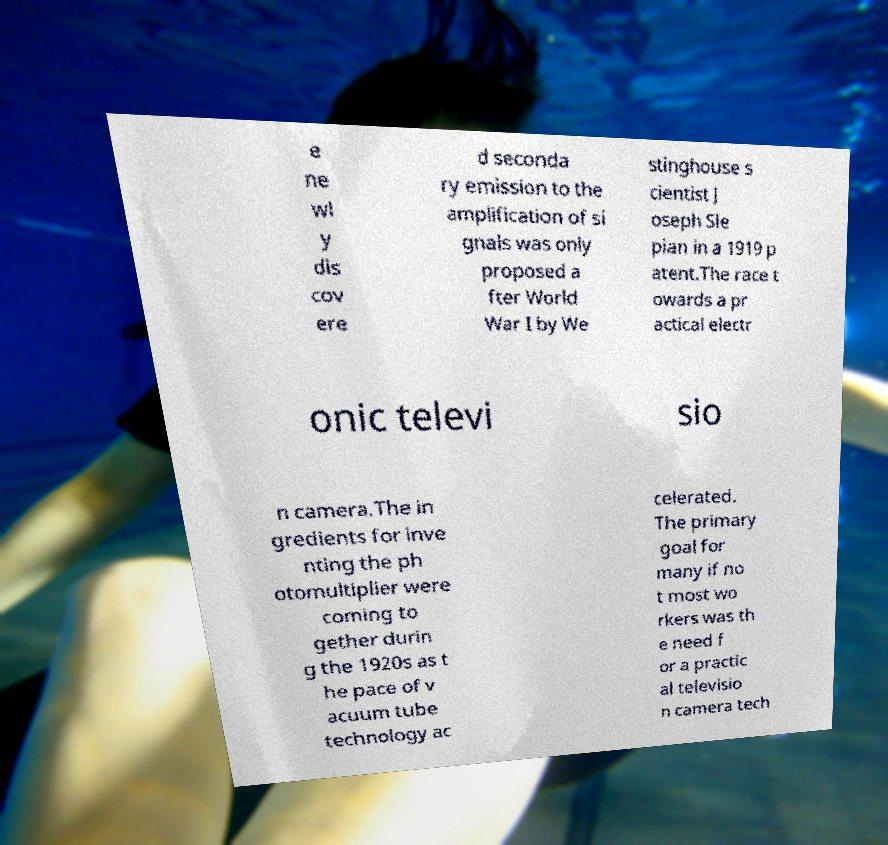There's text embedded in this image that I need extracted. Can you transcribe it verbatim? e ne wl y dis cov ere d seconda ry emission to the amplification of si gnals was only proposed a fter World War I by We stinghouse s cientist J oseph Sle pian in a 1919 p atent.The race t owards a pr actical electr onic televi sio n camera.The in gredients for inve nting the ph otomultiplier were coming to gether durin g the 1920s as t he pace of v acuum tube technology ac celerated. The primary goal for many if no t most wo rkers was th e need f or a practic al televisio n camera tech 